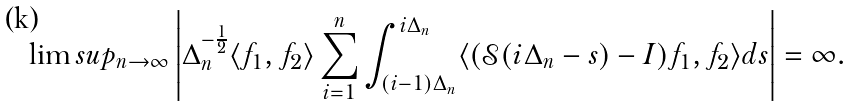Convert formula to latex. <formula><loc_0><loc_0><loc_500><loc_500>\lim s u p _ { n \to \infty } \left | \Delta _ { n } ^ { - \frac { 1 } { 2 } } \langle f _ { 1 } , f _ { 2 } \rangle \sum _ { i = 1 } ^ { n } \int _ { ( i - 1 ) \Delta _ { n } } ^ { i \Delta _ { n } } \langle ( \mathcal { S } ( i \Delta _ { n } - s ) - I ) f _ { 1 } , f _ { 2 } \rangle d s \right | = \infty .</formula> 